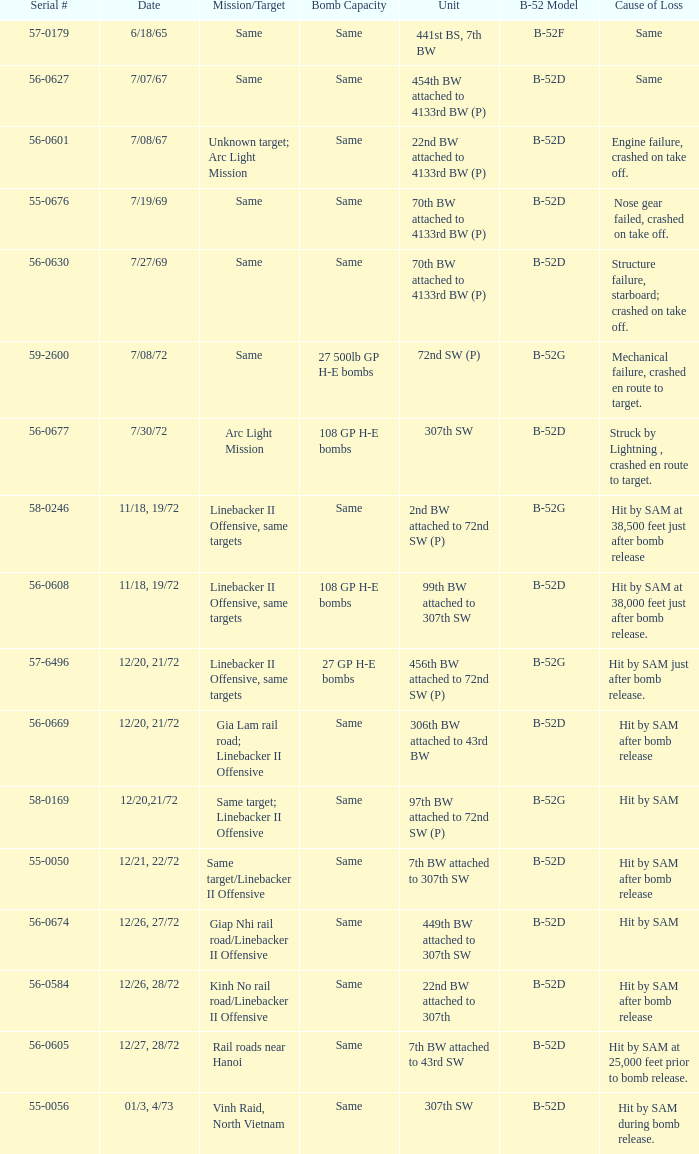When  27 gp h-e bombs the capacity of the bomb what is the cause of loss? Hit by SAM just after bomb release. 